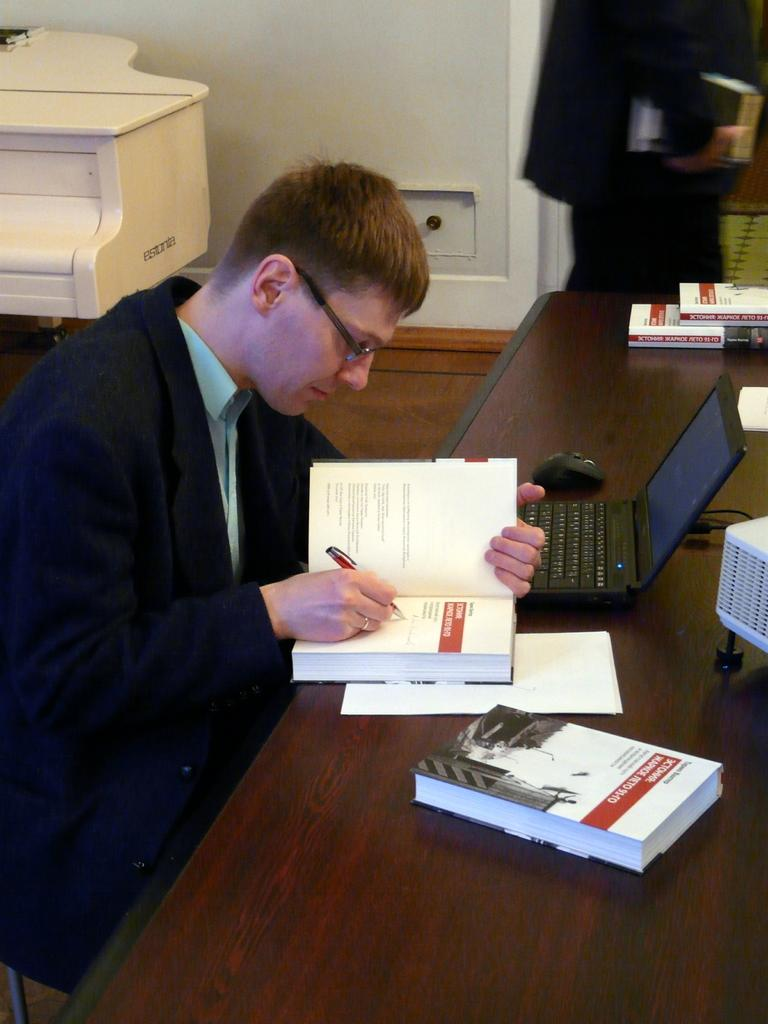Who is present in the picture? There is a man in the picture. What is the man wearing? The man is wearing a blue suit. What is the man doing in the picture? The man is writing in a book. What electronic device is on the table? There is a laptop on the table. What is the shape of the laptop? The laptop is not a specific shape, but it is a rectangular device. What type of cake is on the table? There is no cake present in the image. What color are the feet of the person in the picture? There is no mention of feet in the image, so we cannot determine their color. 